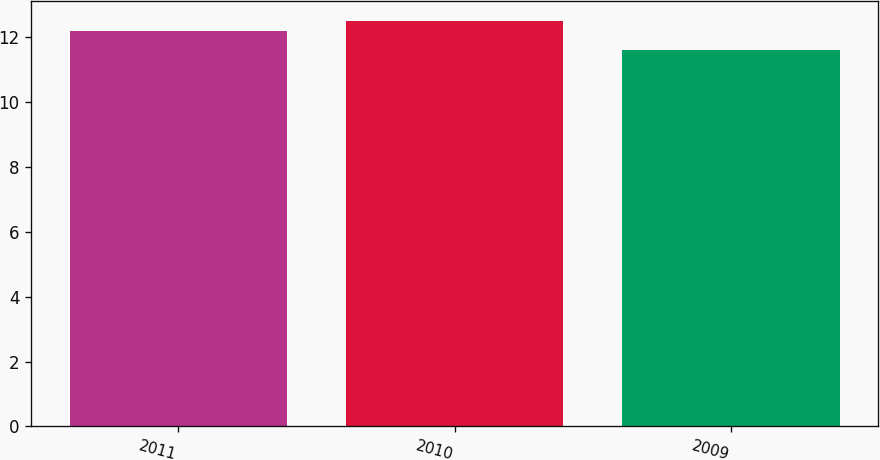Convert chart to OTSL. <chart><loc_0><loc_0><loc_500><loc_500><bar_chart><fcel>2011<fcel>2010<fcel>2009<nl><fcel>12.2<fcel>12.5<fcel>11.6<nl></chart> 